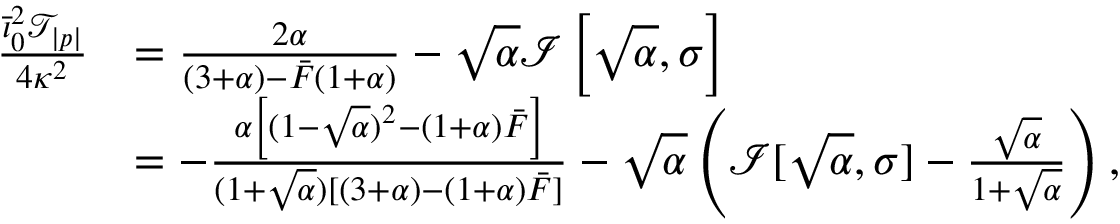<formula> <loc_0><loc_0><loc_500><loc_500>\begin{array} { r l } { \frac { \bar { \iota } _ { 0 } ^ { 2 } \mathcal { T } _ { | p | } } { 4 \kappa ^ { 2 } } } & { = \frac { 2 \alpha } { ( 3 + \alpha ) - \bar { F } ( 1 + \alpha ) } - \sqrt { \alpha } \mathcal { I } \left [ \sqrt { \alpha } , \sigma \right ] } \\ & { = - \frac { \alpha \left [ ( 1 - \sqrt { \alpha } ) ^ { 2 } - ( 1 + \alpha ) \bar { F } \right ] } { ( 1 + \sqrt { \alpha } ) [ ( 3 + \alpha ) - ( 1 + \alpha ) \bar { F } ] } - \sqrt { \alpha } \left ( \mathcal { I } [ \sqrt { \alpha } , \sigma ] - \frac { \sqrt { \alpha } } { 1 + \sqrt { \alpha } } \right ) , } \end{array}</formula> 